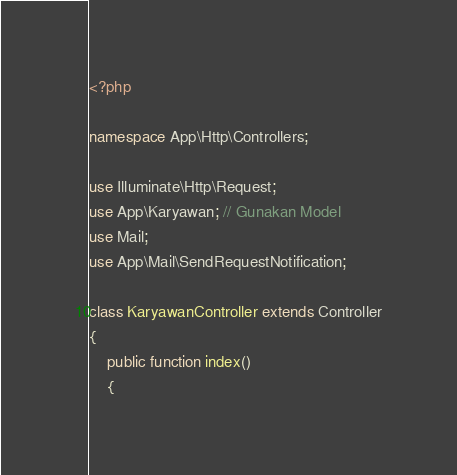<code> <loc_0><loc_0><loc_500><loc_500><_PHP_><?php

namespace App\Http\Controllers;

use Illuminate\Http\Request;
use App\Karyawan; // Gunakan Model
use Mail;
use App\Mail\SendRequestNotification;

class KaryawanController extends Controller
{
    public function index()
    {</code> 